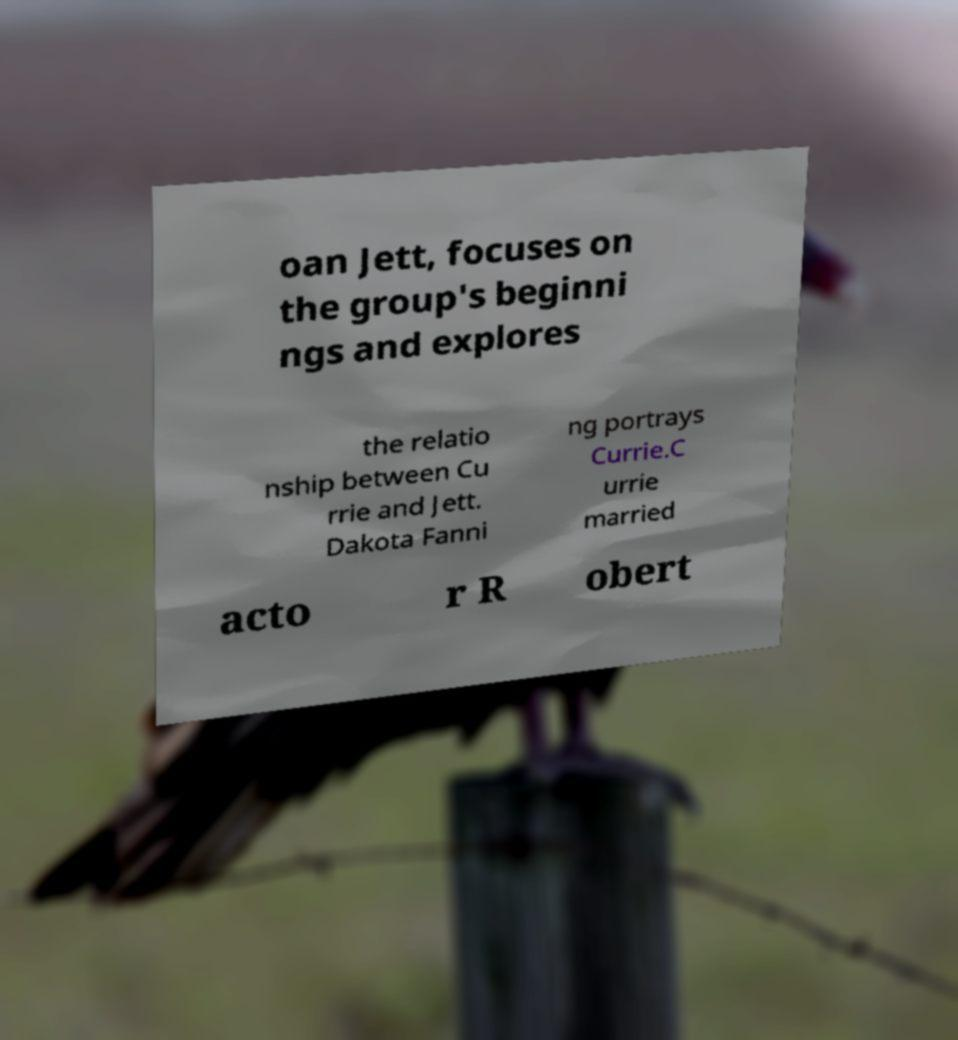Please read and relay the text visible in this image. What does it say? oan Jett, focuses on the group's beginni ngs and explores the relatio nship between Cu rrie and Jett. Dakota Fanni ng portrays Currie.C urrie married acto r R obert 